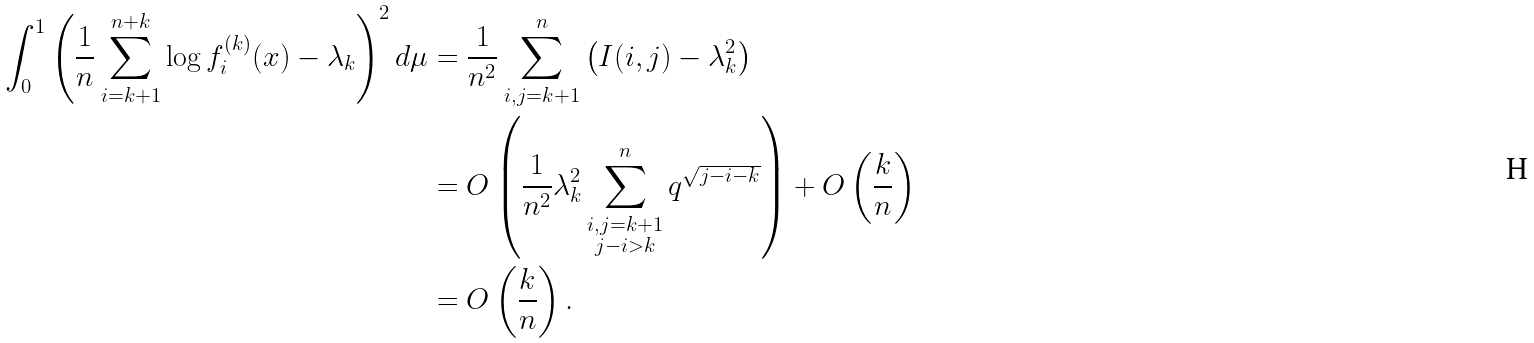Convert formula to latex. <formula><loc_0><loc_0><loc_500><loc_500>\int _ { 0 } ^ { 1 } \left ( \frac { 1 } { n } \sum _ { i = k + 1 } ^ { n + k } \log f _ { i } ^ { ( k ) } ( x ) - \lambda _ { k } \right ) ^ { 2 } d \mu & = \frac { 1 } { n ^ { 2 } } \sum _ { i , j = k + 1 } ^ { n } \left ( I ( i , j ) - \lambda _ { k } ^ { 2 } \right ) \\ & = O \left ( \frac { 1 } { n ^ { 2 } } \lambda _ { k } ^ { 2 } \sum _ { \substack { i , j = k + 1 \\ j - i > k } } ^ { n } q ^ { \sqrt { j - i - k } } \right ) + O \left ( \frac { k } { n } \right ) \\ & = O \left ( \frac { k } { n } \right ) .</formula> 